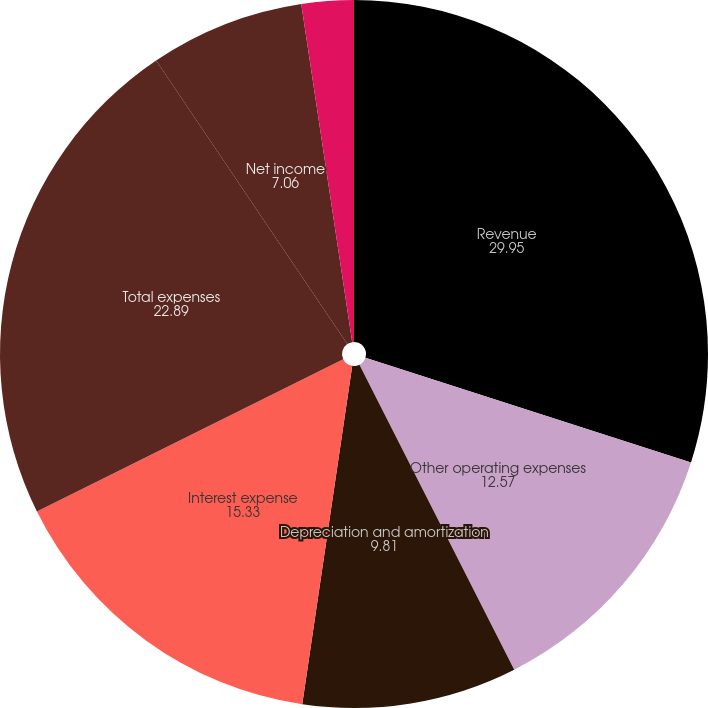Convert chart. <chart><loc_0><loc_0><loc_500><loc_500><pie_chart><fcel>Revenue<fcel>Other operating expenses<fcel>Depreciation and amortization<fcel>Interest expense<fcel>Total expenses<fcel>Net income<fcel>Our share of net income from<nl><fcel>29.95%<fcel>12.57%<fcel>9.81%<fcel>15.33%<fcel>22.89%<fcel>7.06%<fcel>2.38%<nl></chart> 